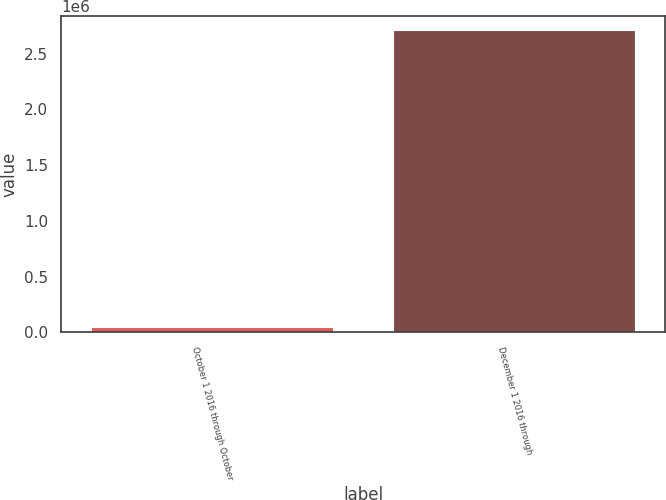Convert chart to OTSL. <chart><loc_0><loc_0><loc_500><loc_500><bar_chart><fcel>October 1 2016 through October<fcel>December 1 2016 through<nl><fcel>44109<fcel>2.7e+06<nl></chart> 